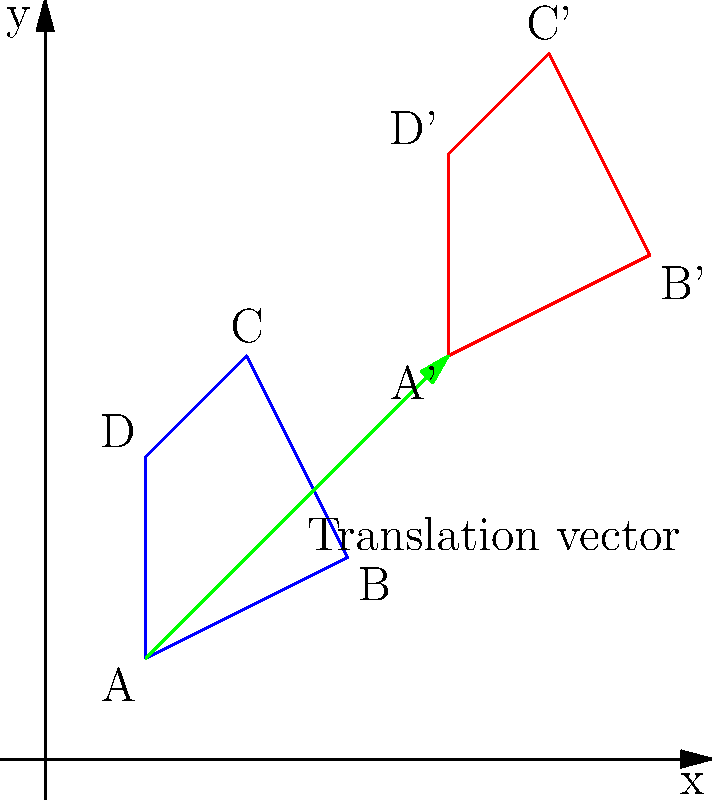In a study of animal migration patterns, a geometric shape representing the movement of a local species is translated across a coordinate plane. The original shape ABCD is translated to A'B'C'D' as shown in the diagram. What is the translation vector that describes this transformation? To find the translation vector, we need to determine how far the shape has moved horizontally and vertically. We can do this by comparing the coordinates of any corresponding point in the original and translated shapes.

Let's use point A(1,1) and its translated position A'(4,4):

1. Calculate the horizontal displacement:
   $x_{displacement} = x_{A'} - x_A = 4 - 1 = 3$

2. Calculate the vertical displacement:
   $y_{displacement} = y_{A'} - y_A = 4 - 1 = 3$

3. The translation vector is represented by these displacements:
   $\vec{v} = (x_{displacement}, y_{displacement}) = (3, 3)$

We can verify this by checking other corresponding points:
- B(3,2) to B'(6,5): (6-3, 5-2) = (3,3)
- C(2,4) to C'(5,7): (5-2, 7-4) = (3,3)
- D(1,3) to D'(4,6): (4-1, 6-3) = (3,3)

All points confirm the same translation vector.
Answer: $(3,3)$ 